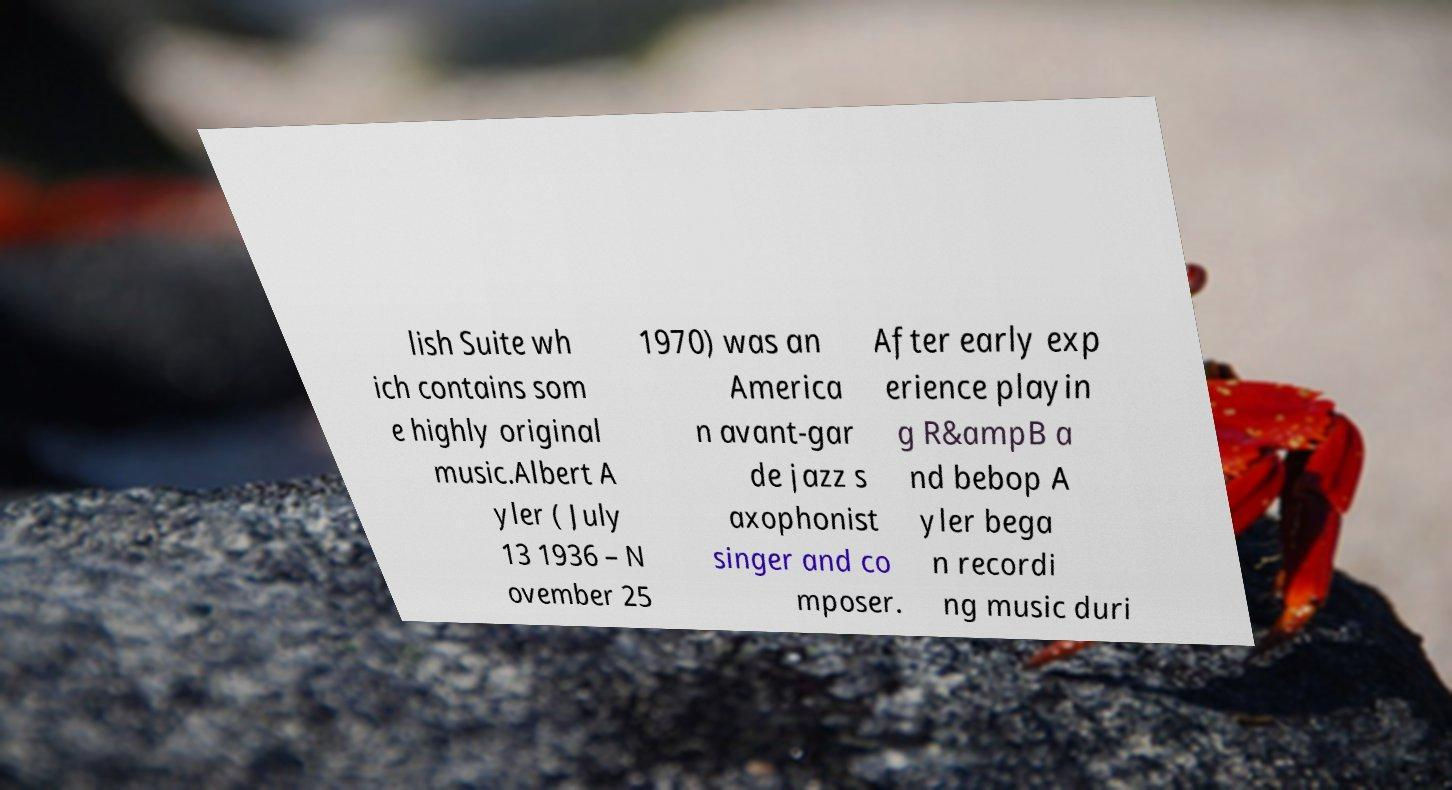I need the written content from this picture converted into text. Can you do that? lish Suite wh ich contains som e highly original music.Albert A yler ( July 13 1936 – N ovember 25 1970) was an America n avant-gar de jazz s axophonist singer and co mposer. After early exp erience playin g R&ampB a nd bebop A yler bega n recordi ng music duri 